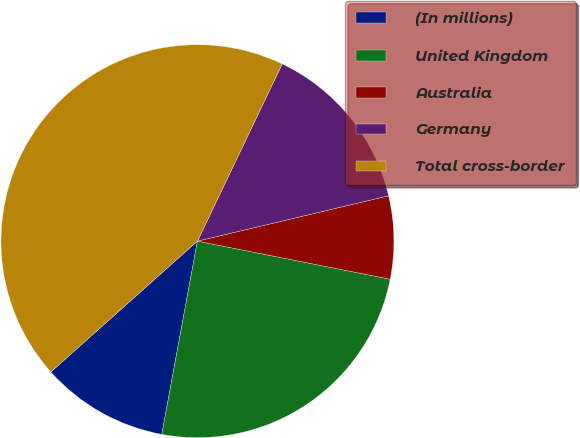<chart> <loc_0><loc_0><loc_500><loc_500><pie_chart><fcel>(In millions)<fcel>United Kingdom<fcel>Australia<fcel>Germany<fcel>Total cross-border<nl><fcel>10.5%<fcel>24.8%<fcel>6.81%<fcel>14.19%<fcel>43.7%<nl></chart> 